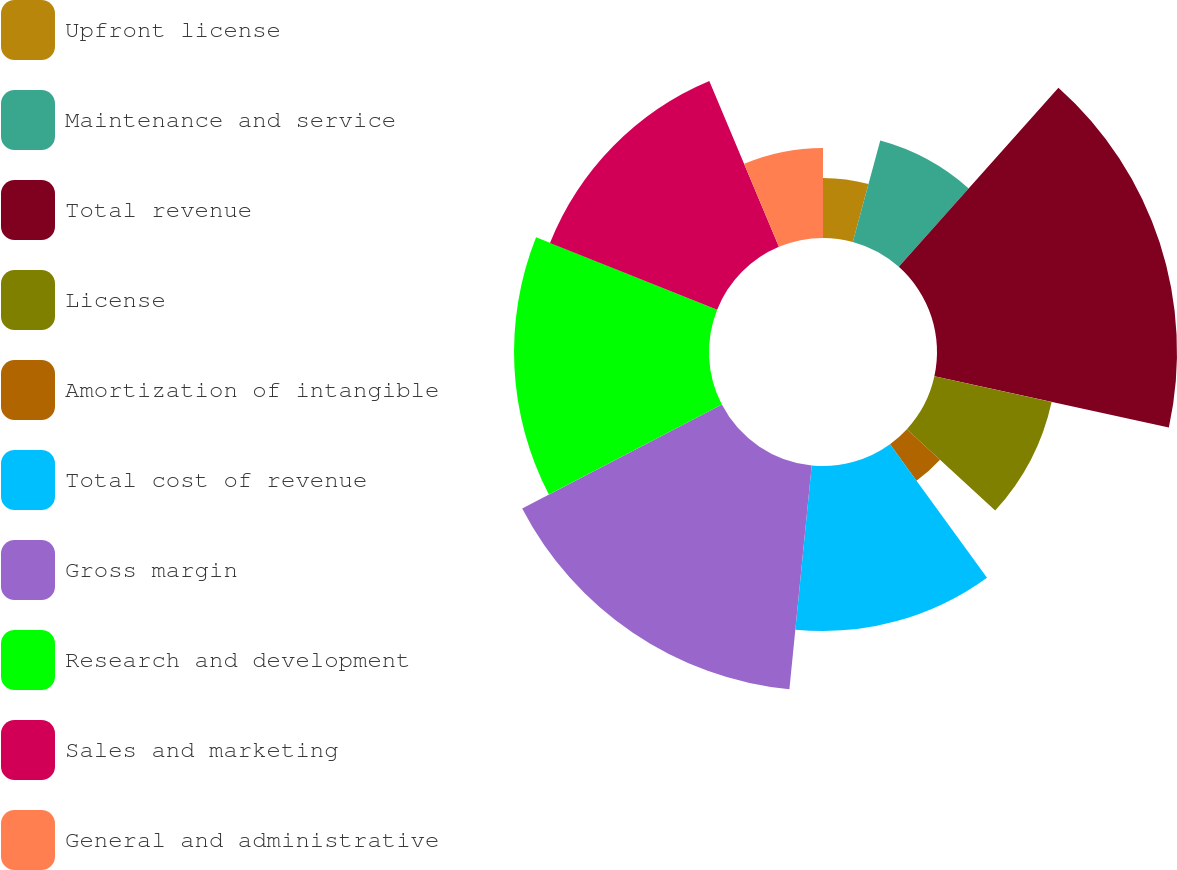Convert chart to OTSL. <chart><loc_0><loc_0><loc_500><loc_500><pie_chart><fcel>Upfront license<fcel>Maintenance and service<fcel>Total revenue<fcel>License<fcel>Amortization of intangible<fcel>Total cost of revenue<fcel>Gross margin<fcel>Research and development<fcel>Sales and marketing<fcel>General and administrative<nl><fcel>4.21%<fcel>7.37%<fcel>16.84%<fcel>8.42%<fcel>3.16%<fcel>11.58%<fcel>15.79%<fcel>13.68%<fcel>12.63%<fcel>6.32%<nl></chart> 